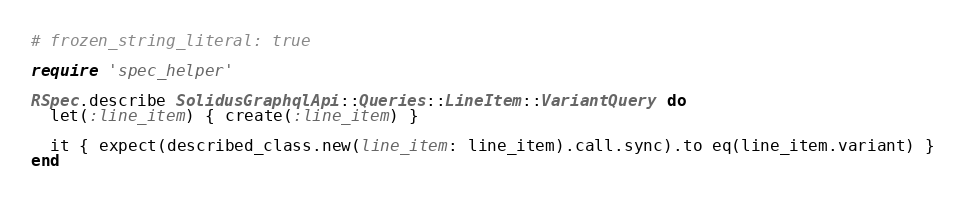<code> <loc_0><loc_0><loc_500><loc_500><_Ruby_># frozen_string_literal: true

require 'spec_helper'

RSpec.describe SolidusGraphqlApi::Queries::LineItem::VariantQuery do
  let(:line_item) { create(:line_item) }

  it { expect(described_class.new(line_item: line_item).call.sync).to eq(line_item.variant) }
end
</code> 